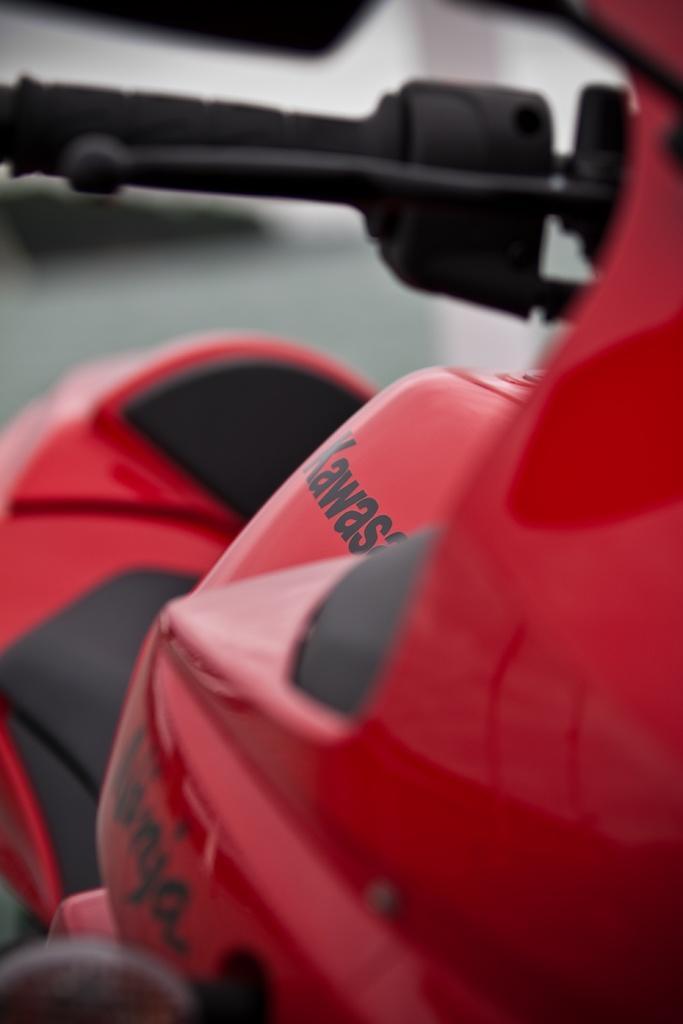Please provide a concise description of this image. In this picture I can see there is a motor cycle and it is in red color and it has a black handle and a black color brake and there is something written on the engine. 